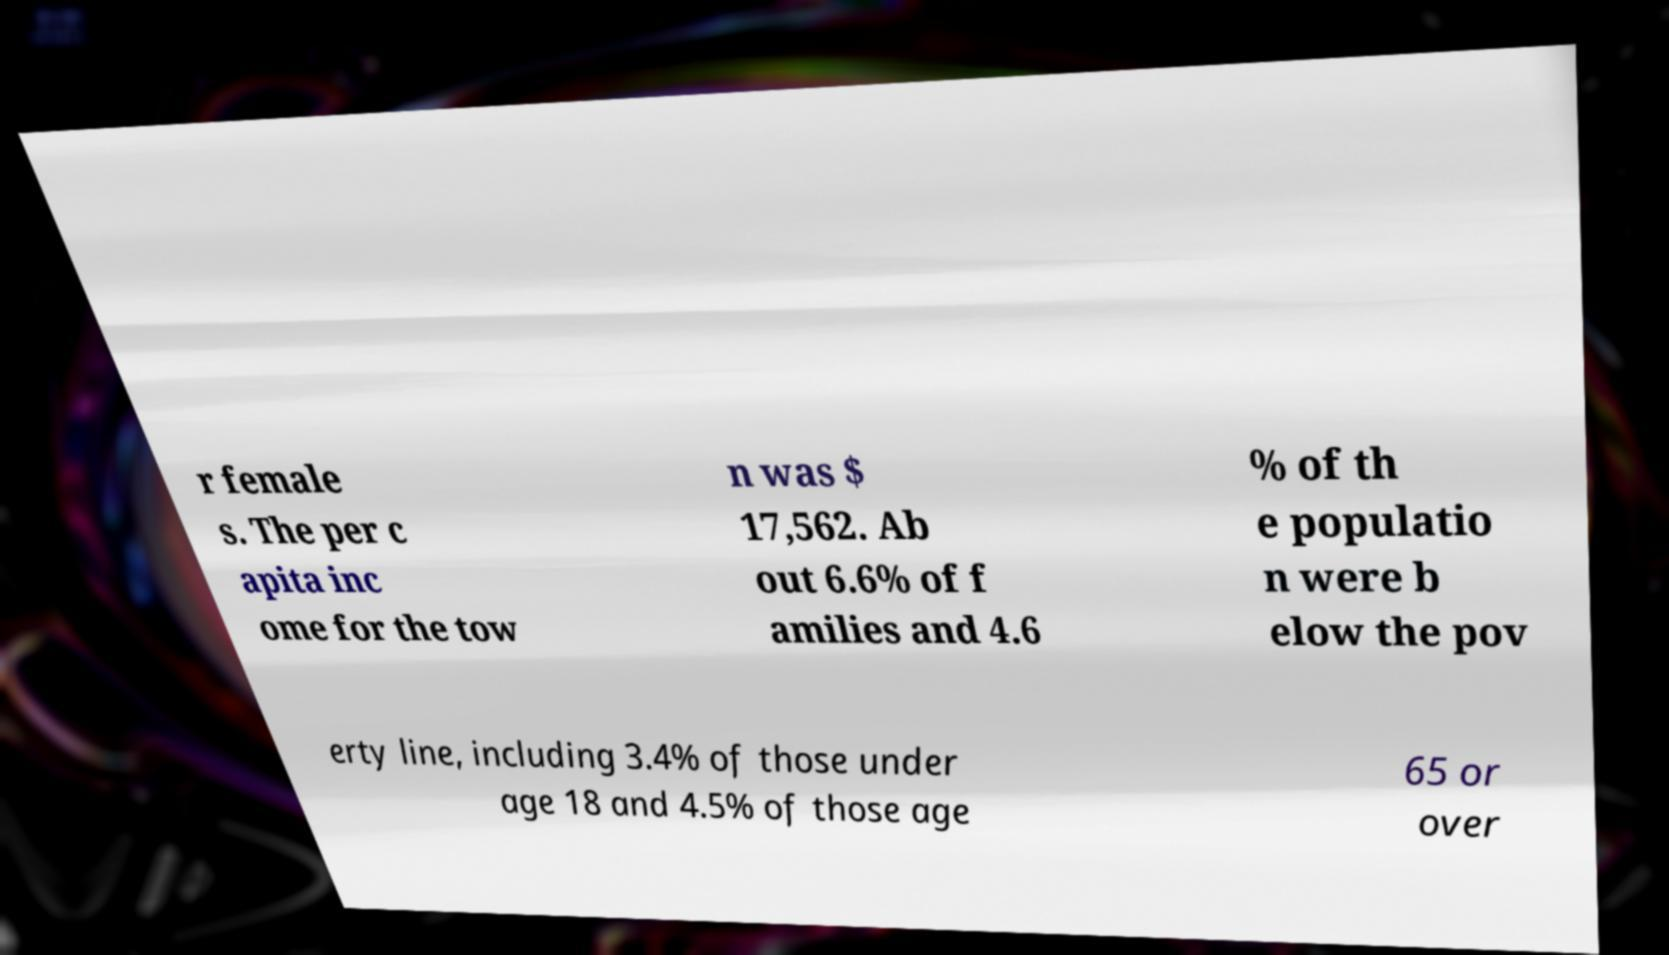Could you extract and type out the text from this image? r female s. The per c apita inc ome for the tow n was $ 17,562. Ab out 6.6% of f amilies and 4.6 % of th e populatio n were b elow the pov erty line, including 3.4% of those under age 18 and 4.5% of those age 65 or over 